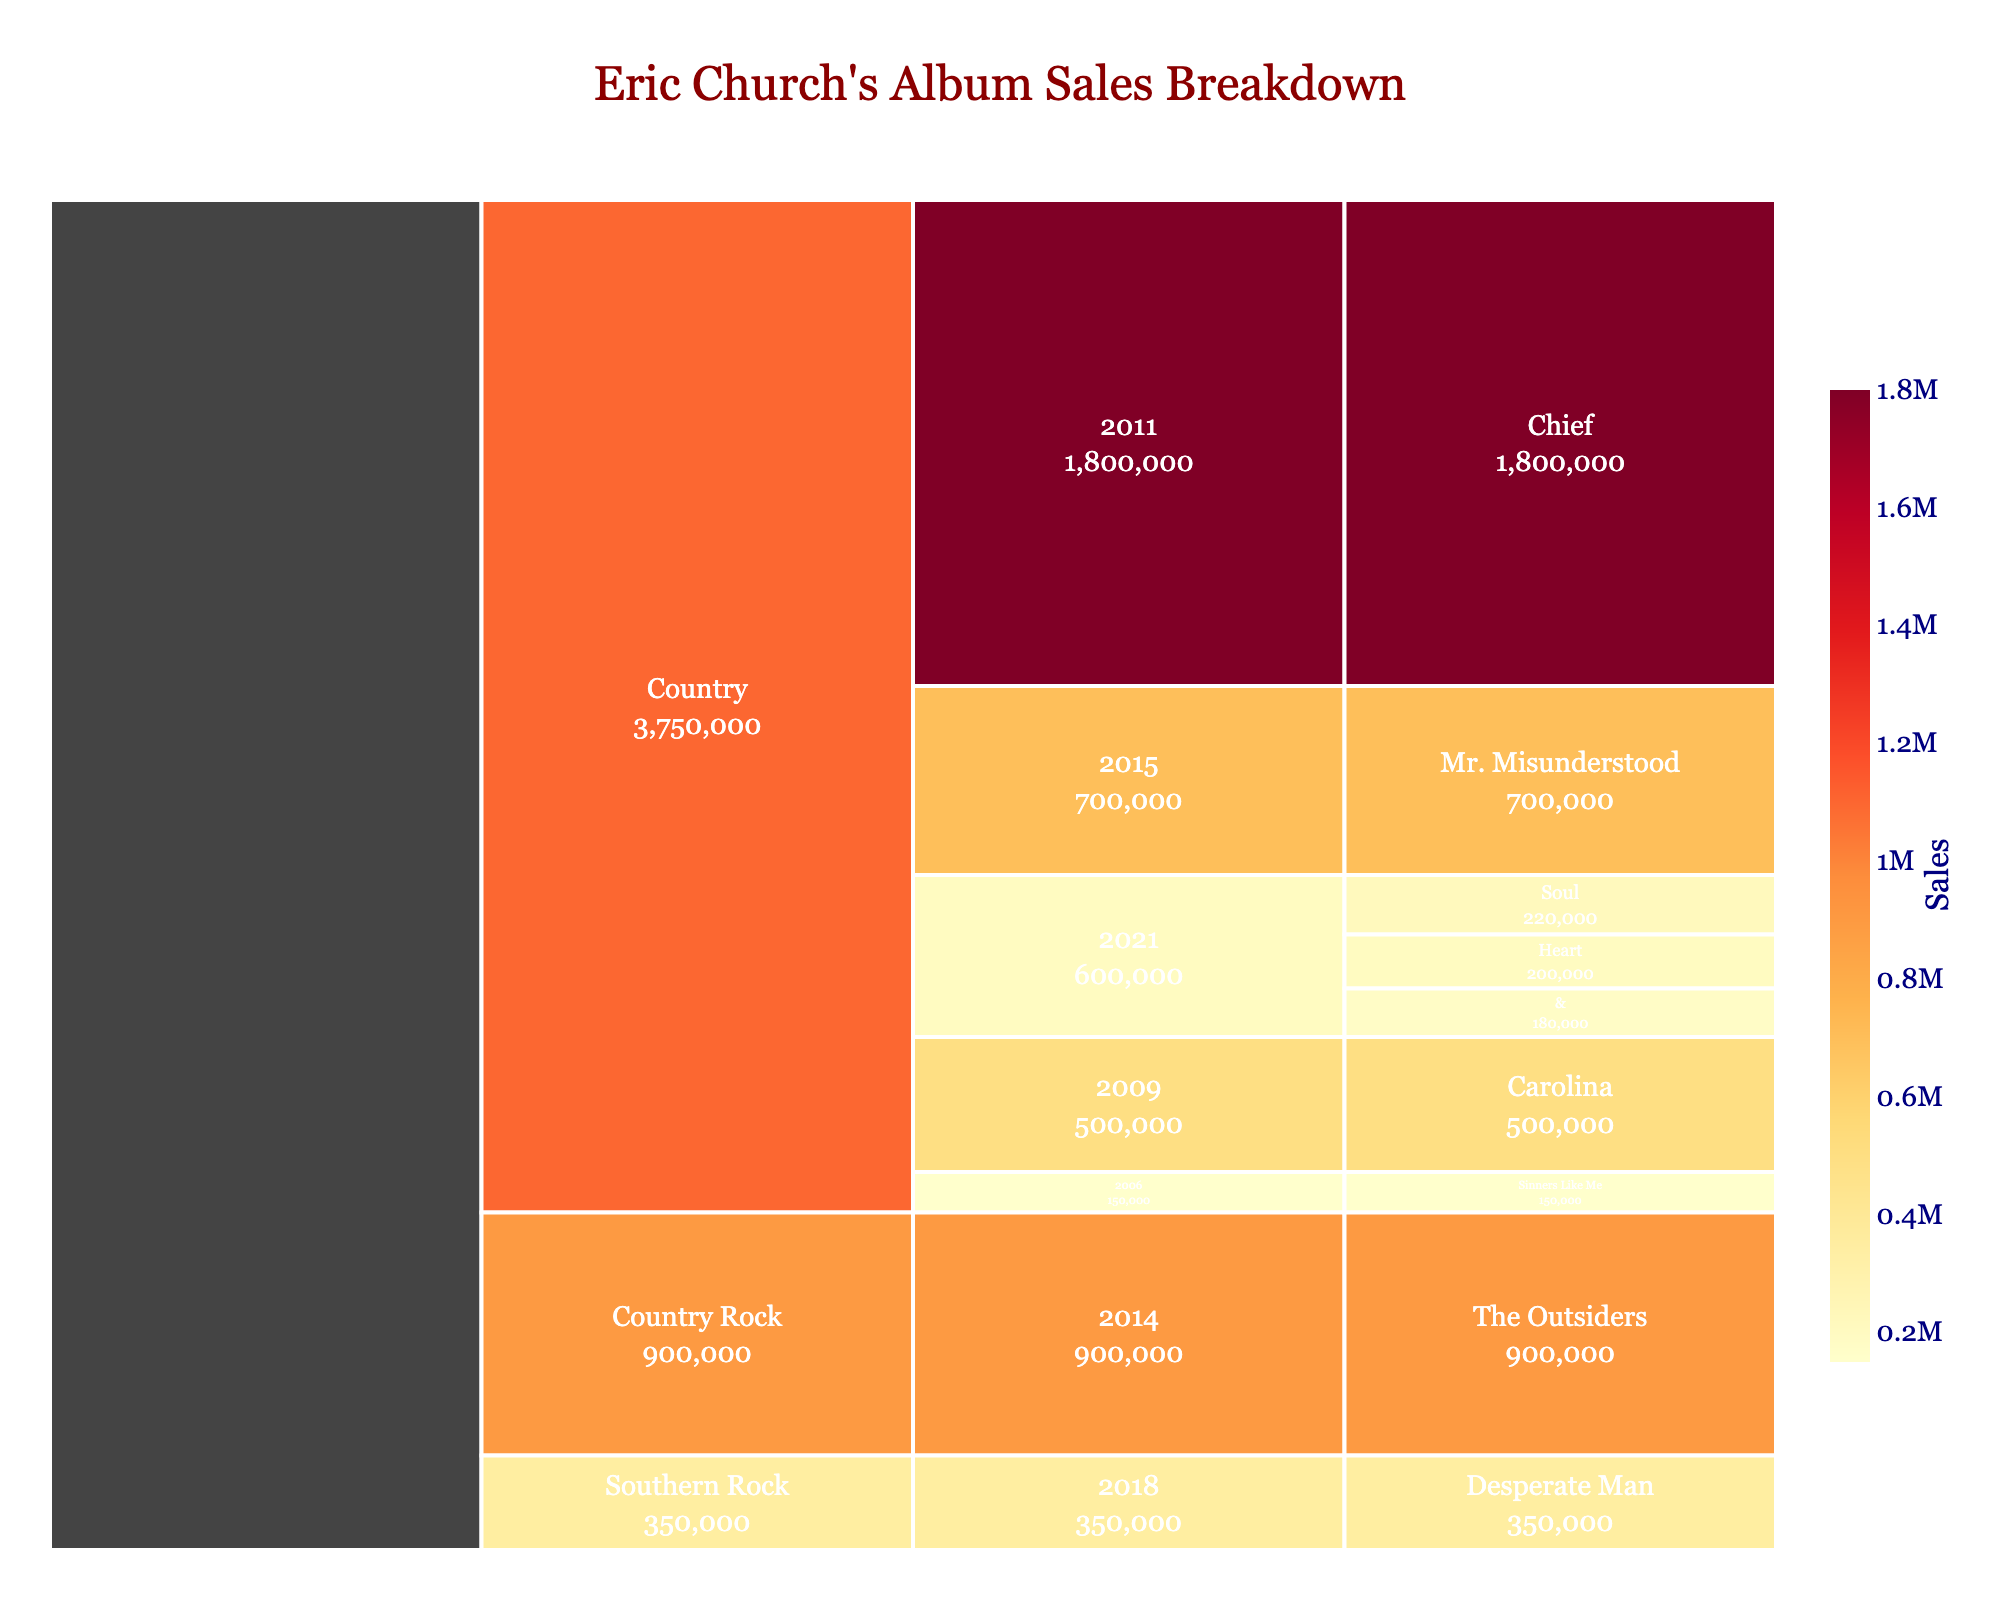What's the title of the chart? The title is usually displayed prominently at the top of the chart. Here, it reads "Eric Church's Album Sales Breakdown".
Answer: Eric Church's Album Sales Breakdown Which album had the highest sales? In the icicle chart, the size of each segment represents the sales, and by looking for the largest segment, we identify the "Chief" album.
Answer: Chief In which year did Eric Church release three albums? The icicle chart displays the albums organized by year. By examining the year branches, 2021 shows three albums ("Heart", "&", "Soul").
Answer: 2021 How many genres are depicted in the chart? The icicle chart starts with genres at the top level. By counting these top-level labels, we find there are three genres: Country, Country Rock, and Southern Rock.
Answer: 3 What are the total sales for Eric Church's albums released in 2021? Sum the sales of the albums released in 2021 ("Heart": 200,000 + "&": 180,000 + "Soul": 220,000). This gives a total of 600,000 sales.
Answer: 600,000 What is the difference in sales between "Chief" and "The Outsiders"? The sales for "Chief" are 1,800,000 and for "The Outsiders" are 900,000. The difference is calculated as 1,800,000 - 900,000.
Answer: 900,000 Which genre has the least total album sales? By summing the sales for each genre and comparing them, Southern Rock with "Desperate Man" having 350,000 is the smallest total.
Answer: Southern Rock Does the color of the segments provide additional information? Yes, the chart uses a color scale where colors represent varying values of sales, helping visualize which segments have higher or lower sales.
Answer: Yes How do the sales of "Mr. Misunderstood" compare to those of "Desperate Man"? "Mr. Misunderstood" has 700,000 sales, while "Desperate Man" has 350,000 sales. Since 700,000 is greater than 350,000, "Mr. Misunderstood" has higher sales.
Answer: Mr. Misunderstood has higher sales What is the total sales for the genre "Country"? Summing up the sales for all Country genre albums: "Sinners Like Me" (150,000) + "Carolina" (500,000) + "Chief" (1,800,000) + "Mr. Misunderstood" (700,000) + "Heart" (200,000) + "&" (180,000) + "Soul" (220,000) equals 3,750,000.
Answer: 3,750,000 